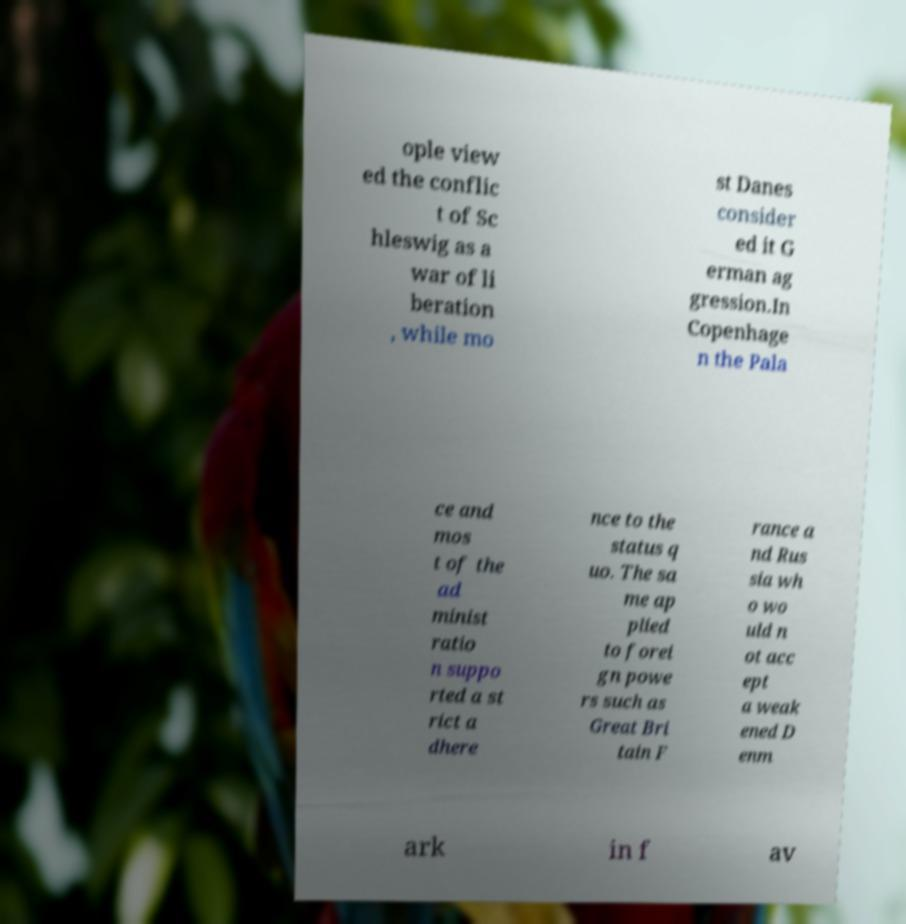There's text embedded in this image that I need extracted. Can you transcribe it verbatim? ople view ed the conflic t of Sc hleswig as a war of li beration , while mo st Danes consider ed it G erman ag gression.In Copenhage n the Pala ce and mos t of the ad minist ratio n suppo rted a st rict a dhere nce to the status q uo. The sa me ap plied to forei gn powe rs such as Great Bri tain F rance a nd Rus sia wh o wo uld n ot acc ept a weak ened D enm ark in f av 